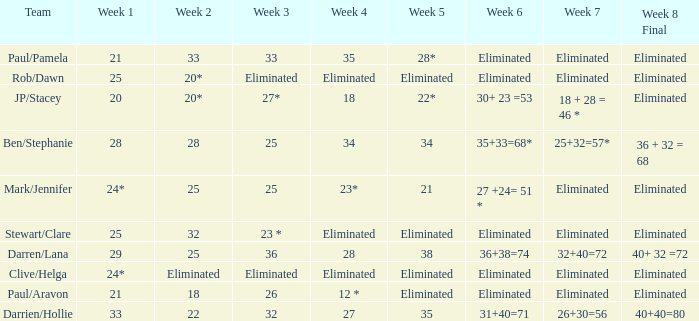Name the team for week 1 of 28 Ben/Stephanie. 